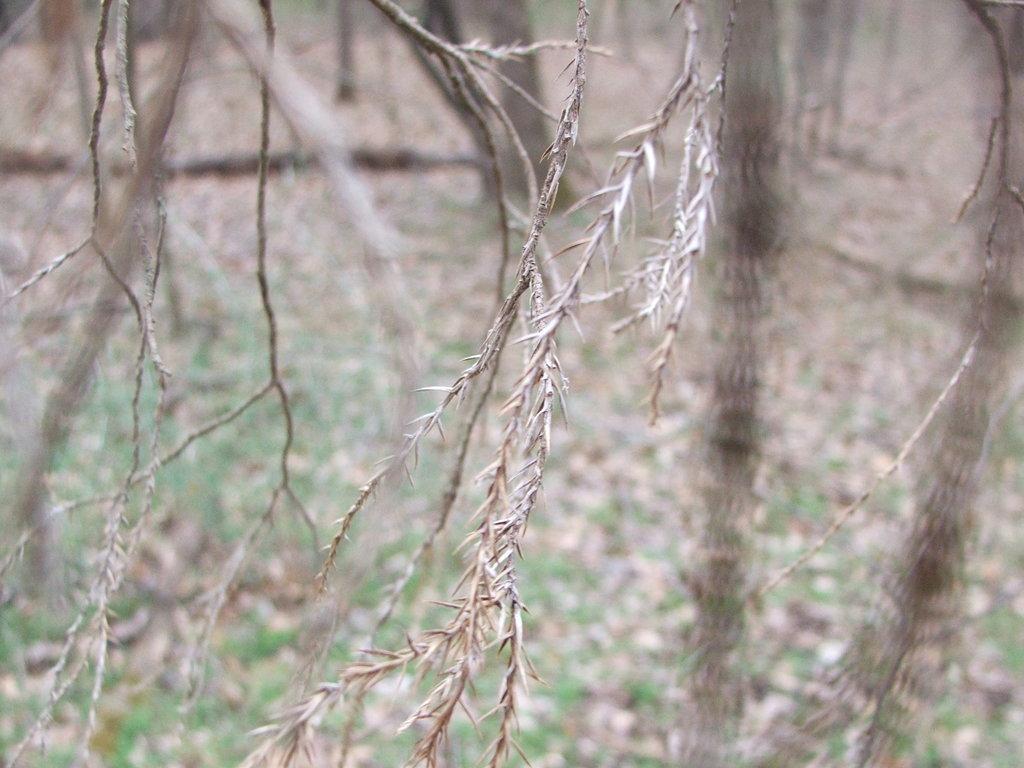Could you give a brief overview of what you see in this image? In this picture I can see the branches. In the background I can see the trees, grass and dry leaves. 